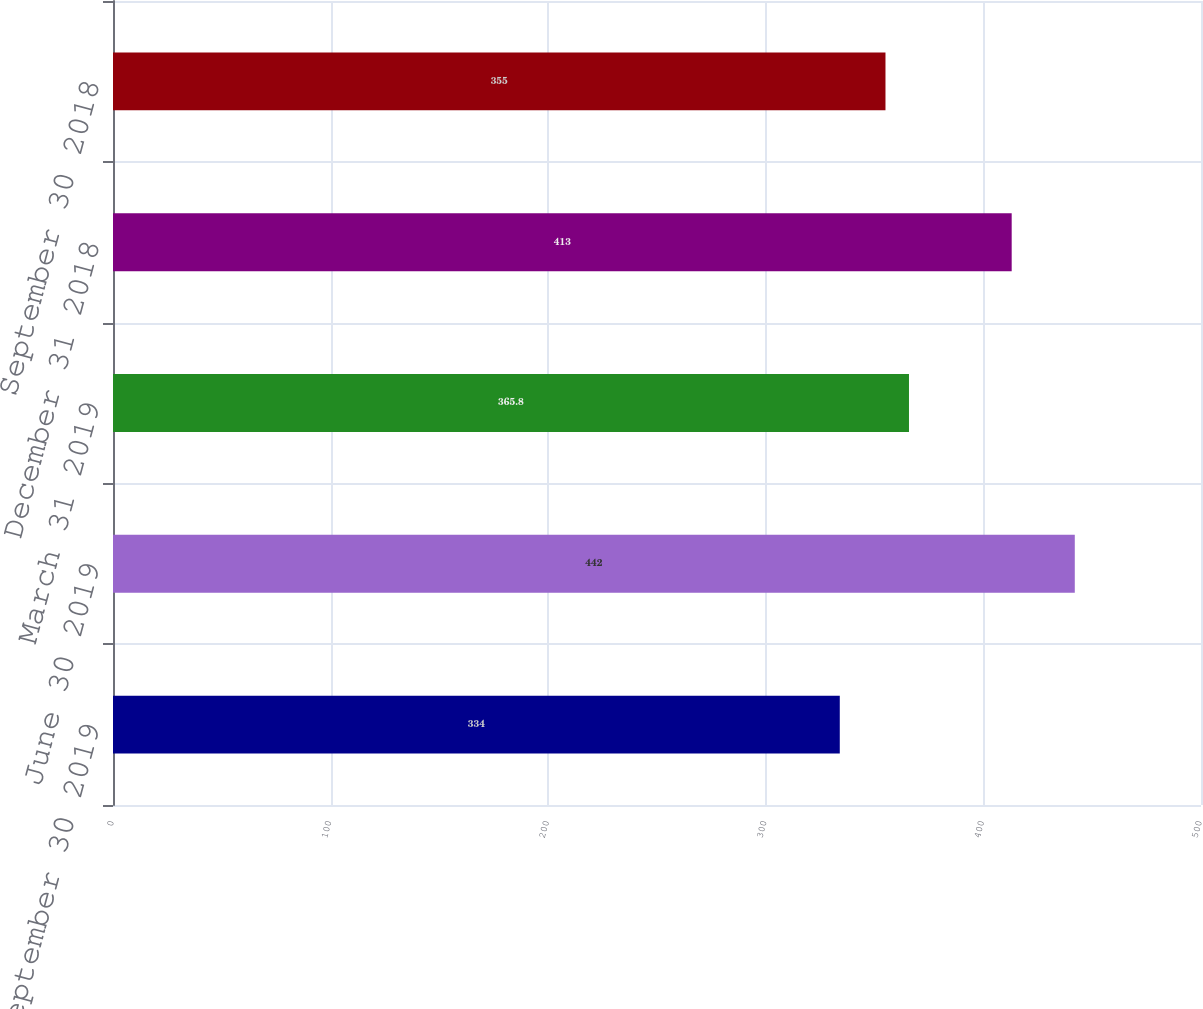Convert chart to OTSL. <chart><loc_0><loc_0><loc_500><loc_500><bar_chart><fcel>September 30 2019<fcel>June 30 2019<fcel>March 31 2019<fcel>December 31 2018<fcel>September 30 2018<nl><fcel>334<fcel>442<fcel>365.8<fcel>413<fcel>355<nl></chart> 